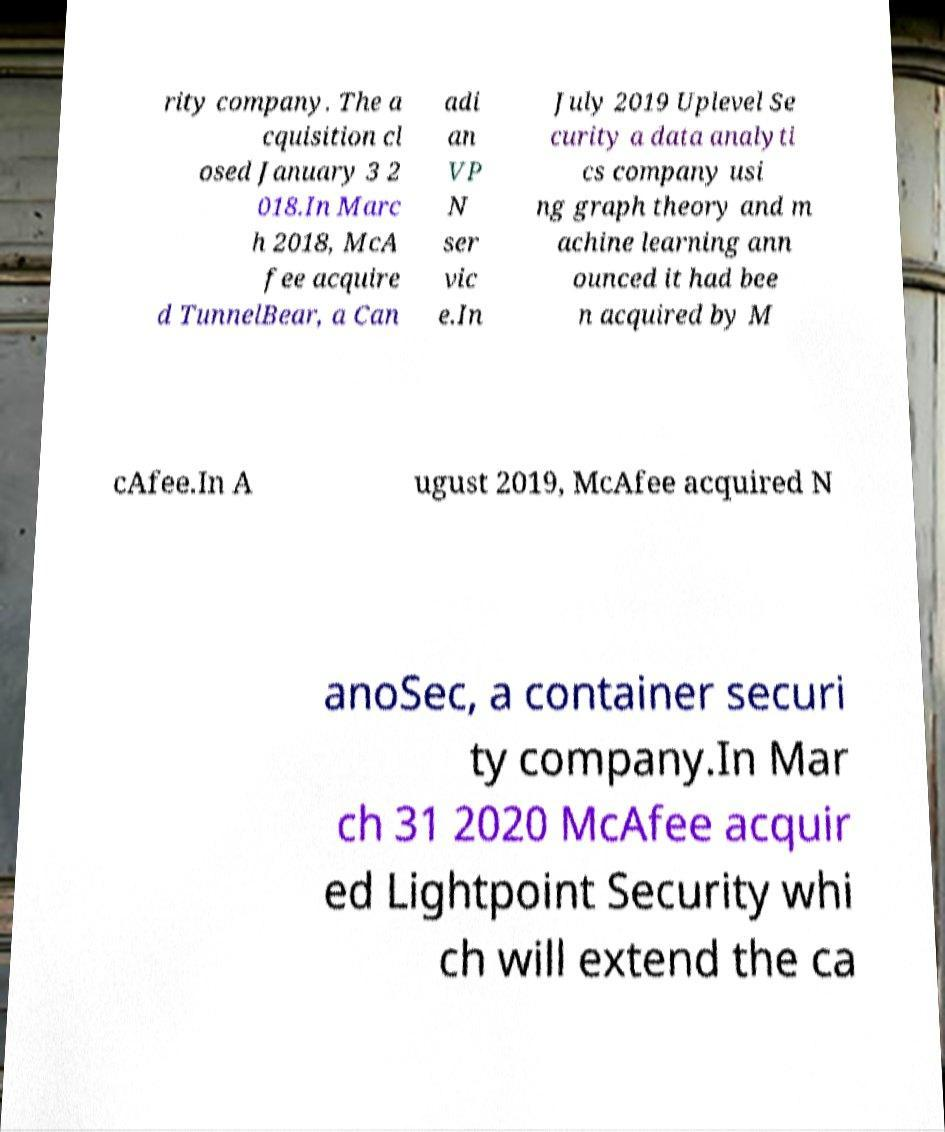Can you read and provide the text displayed in the image?This photo seems to have some interesting text. Can you extract and type it out for me? rity company. The a cquisition cl osed January 3 2 018.In Marc h 2018, McA fee acquire d TunnelBear, a Can adi an VP N ser vic e.In July 2019 Uplevel Se curity a data analyti cs company usi ng graph theory and m achine learning ann ounced it had bee n acquired by M cAfee.In A ugust 2019, McAfee acquired N anoSec, a container securi ty company.In Mar ch 31 2020 McAfee acquir ed Lightpoint Security whi ch will extend the ca 